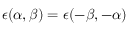Convert formula to latex. <formula><loc_0><loc_0><loc_500><loc_500>\epsilon ( \alpha , \beta ) = \epsilon ( - \beta , - \alpha )</formula> 